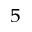Convert formula to latex. <formula><loc_0><loc_0><loc_500><loc_500>_ { 5 }</formula> 